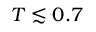Convert formula to latex. <formula><loc_0><loc_0><loc_500><loc_500>T \lesssim 0 . 7</formula> 